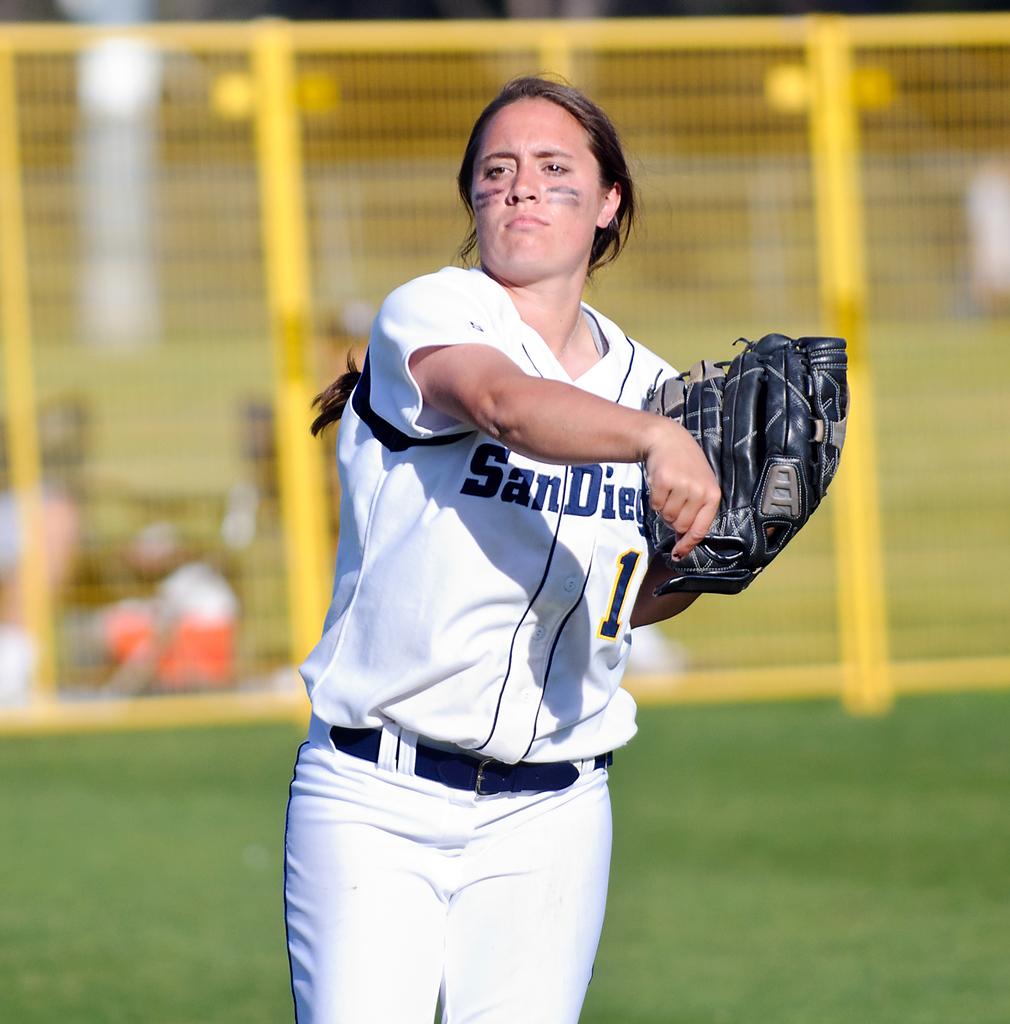What team does the girl play for?
Provide a succinct answer. San diego. What number can be seen in the woman shirt?
Your answer should be compact. 1. 